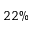<formula> <loc_0><loc_0><loc_500><loc_500>2 2 \%</formula> 